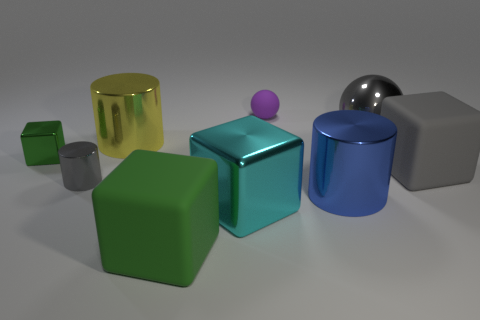Add 1 big gray rubber spheres. How many objects exist? 10 Subtract all balls. How many objects are left? 7 Subtract 0 blue blocks. How many objects are left? 9 Subtract all yellow cylinders. Subtract all small green metallic things. How many objects are left? 7 Add 4 purple matte spheres. How many purple matte spheres are left? 5 Add 3 yellow shiny cylinders. How many yellow shiny cylinders exist? 4 